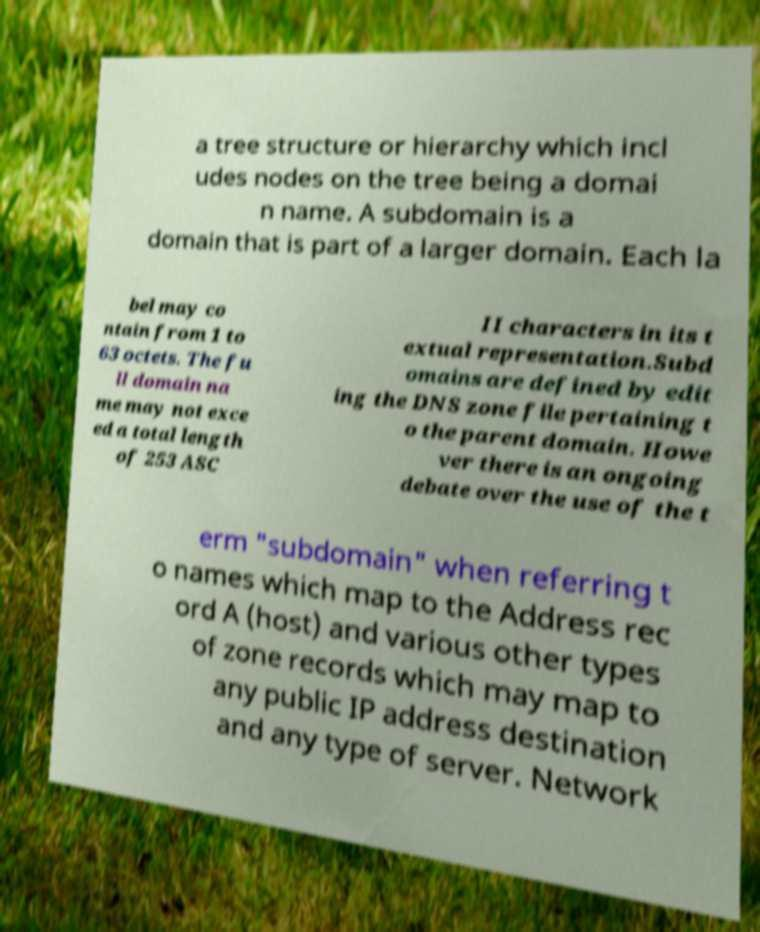For documentation purposes, I need the text within this image transcribed. Could you provide that? a tree structure or hierarchy which incl udes nodes on the tree being a domai n name. A subdomain is a domain that is part of a larger domain. Each la bel may co ntain from 1 to 63 octets. The fu ll domain na me may not exce ed a total length of 253 ASC II characters in its t extual representation.Subd omains are defined by edit ing the DNS zone file pertaining t o the parent domain. Howe ver there is an ongoing debate over the use of the t erm "subdomain" when referring t o names which map to the Address rec ord A (host) and various other types of zone records which may map to any public IP address destination and any type of server. Network 